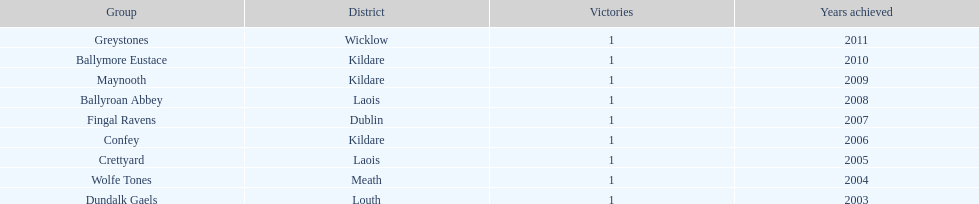Would you mind parsing the complete table? {'header': ['Group', 'District', 'Victories', 'Years achieved'], 'rows': [['Greystones', 'Wicklow', '1', '2011'], ['Ballymore Eustace', 'Kildare', '1', '2010'], ['Maynooth', 'Kildare', '1', '2009'], ['Ballyroan Abbey', 'Laois', '1', '2008'], ['Fingal Ravens', 'Dublin', '1', '2007'], ['Confey', 'Kildare', '1', '2006'], ['Crettyard', 'Laois', '1', '2005'], ['Wolfe Tones', 'Meath', '1', '2004'], ['Dundalk Gaels', 'Louth', '1', '2003']]} Which team claimed victory after ballymore eustace? Greystones. 